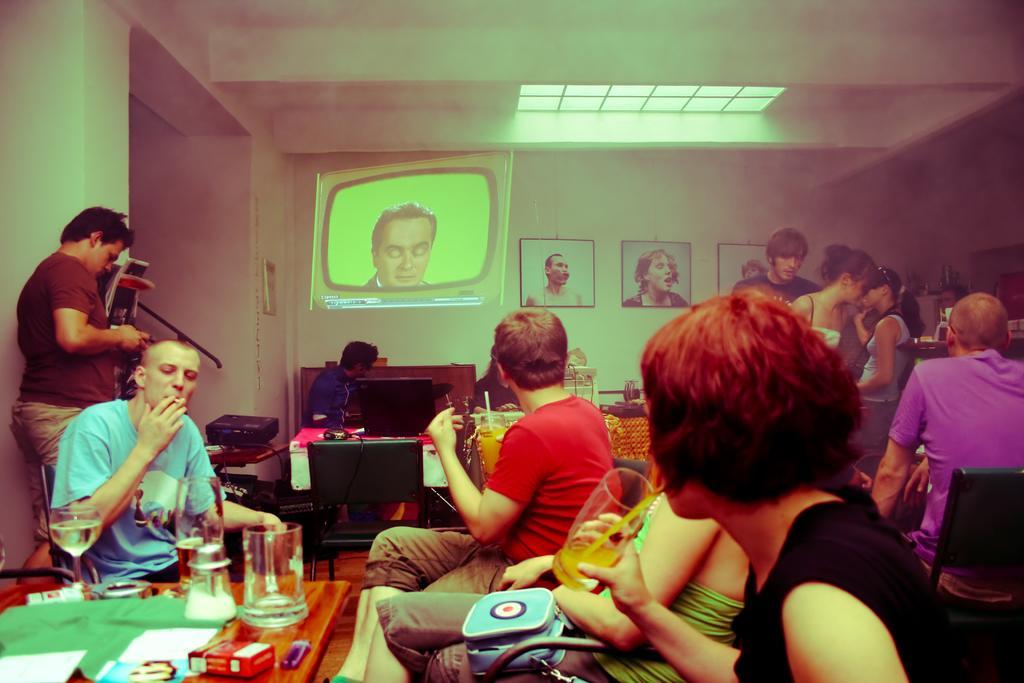Could you give a brief overview of what you see in this image? There are group of people sitting on the chairs and few are standing. This is a table with a tumbler,wine glass and some objects on it. And here is the another table with a monitor screen. These are the photo frames attached to the wall. I can see a blue colored bag which is on the women lap. I can see another object placed on the other table. This looks like a artificial television screen on the wall. 